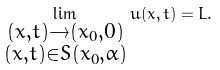Convert formula to latex. <formula><loc_0><loc_0><loc_500><loc_500>\lim _ { \substack { ( x , t ) \to ( x _ { 0 } , 0 ) \\ ( x , t ) \in S ( x _ { 0 } , \alpha ) } } u ( x , t ) = L .</formula> 